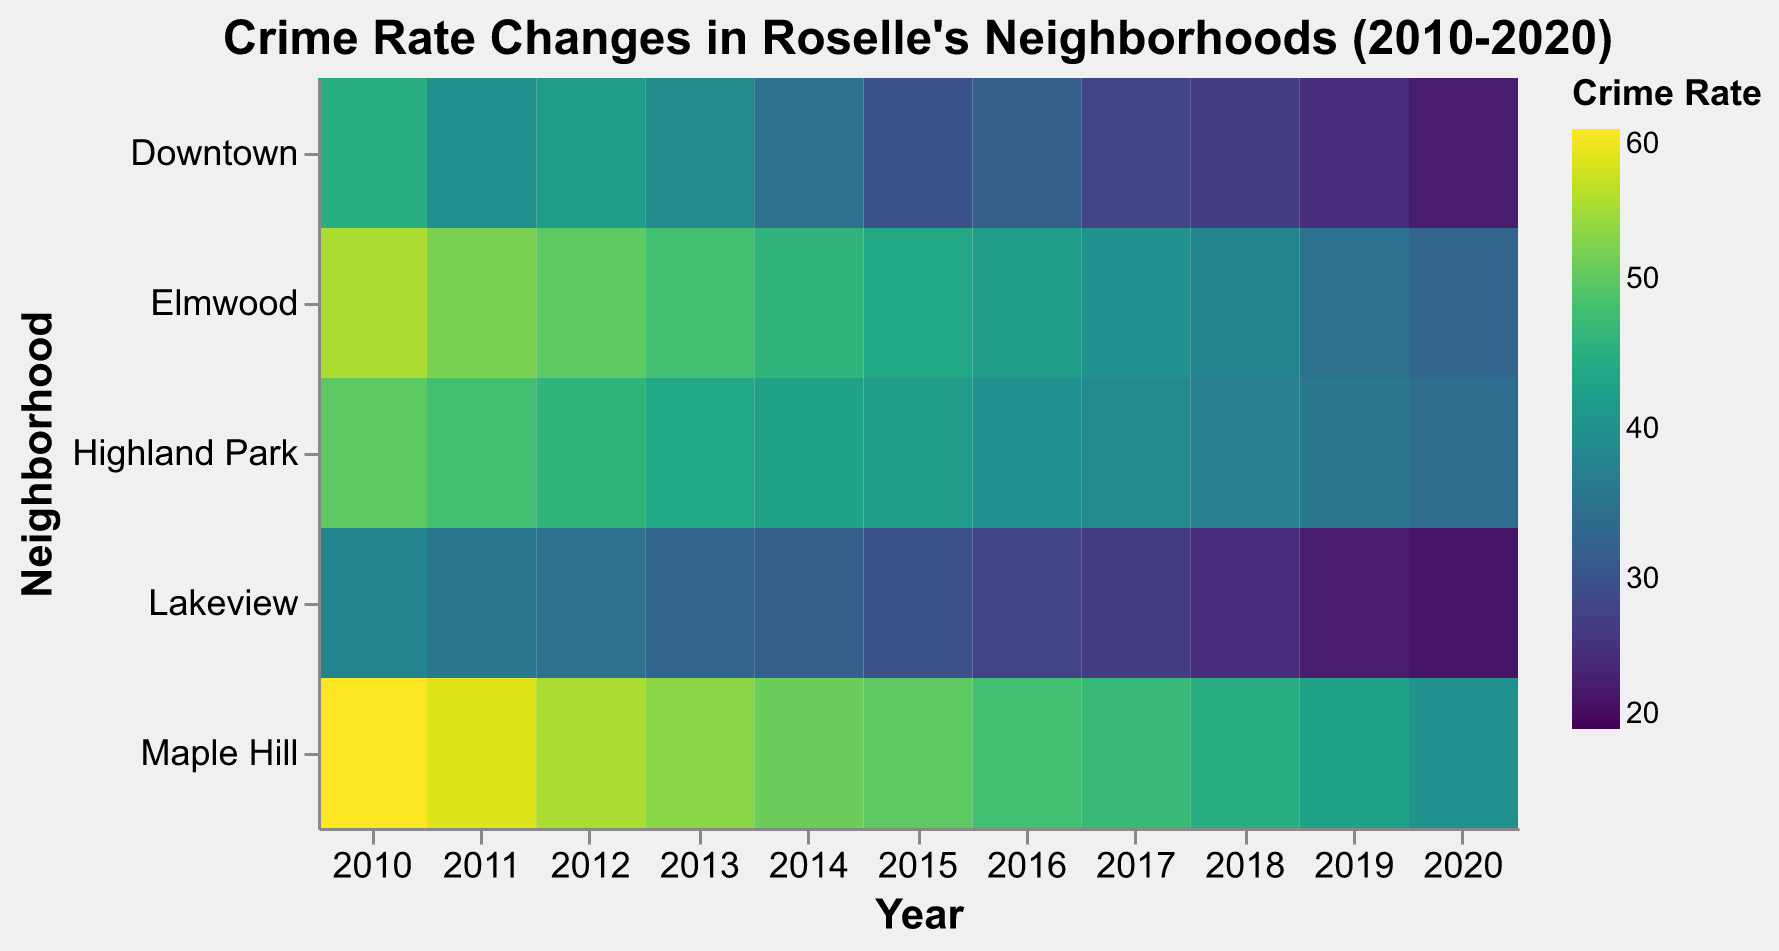What's the title of the figure? The title of the figure can be found at the top and it is clearly written in bold typeface with larger font size.
Answer: Crime Rate Changes in Roselle's Neighborhoods (2010-2020) How does the crime rate in Downtown in 2010 compare to 2020? Look at the color intensity for Downtown in 2010 and 2020; 2010 shows a lighter color which indicates a higher crime rate. Also, the numbers directly confirm this change.
Answer: It decreased from 45 to 23 Which neighborhood had the highest crime rate in 2010? Evaluate the colors for each neighborhood in 2010, and identify the one with the most intense color indicating the highest rate; also, compare the numerical values.
Answer: Maple Hill Has the crime rate in Elmwood consistently decreased over the years? Inspect the trend in color intensity for Elmwood from 2010 to 2020 and observe the numerical values to see a consistent pattern.
Answer: Yes, it has decreased Which neighborhood had the lowest crime rate in 2020? Evaluate the colors for each neighborhood for the year 2020, focusing on the least intense (lightest) color; also, check the numerical values.
Answer: Lakeview Calculate the average crime rate in Lakeview from 2018 to 2020. Add the crime rates of Lakeview for the years 2018, 2019, and 2020, and then divide by 3 to find the average: (25 + 23 + 22) / 3.
Answer: 23.33 Which neighborhood had the most significant reduction in crime rate from 2010 to 2020? Find the difference in crime rates for each neighborhood between 2010 and 2020 and identify the largest difference. Downtown: 22, Elmwood: 22, Maple Hill: 20, Lakeview: 16, Highland Park: 16. Downtown and Elmwood both have 22.
Answer: Downtown and Elmwood Are there any neighborhoods with the same crime rate in 2015? Check the chart for 2015 and look for any neighborhoods that share the same color intensity and verify with the numerical values.
Answer: No Which year shows the lowest crime rate for Highland Park? Inspect the colors for Highland Park across all years; the year with the least intense color marks the lowest crime rate. Validate with numerical values.
Answer: 2020 What is the total crime rate for Elmwood over the decade? Sum all the crime rates for Elmwood from 2010 to 2020. Calculate: 55 + 52 + 50 + 48 + 46 + 44 + 42 + 40 + 38 + 35 + 33 = 483
Answer: 483 